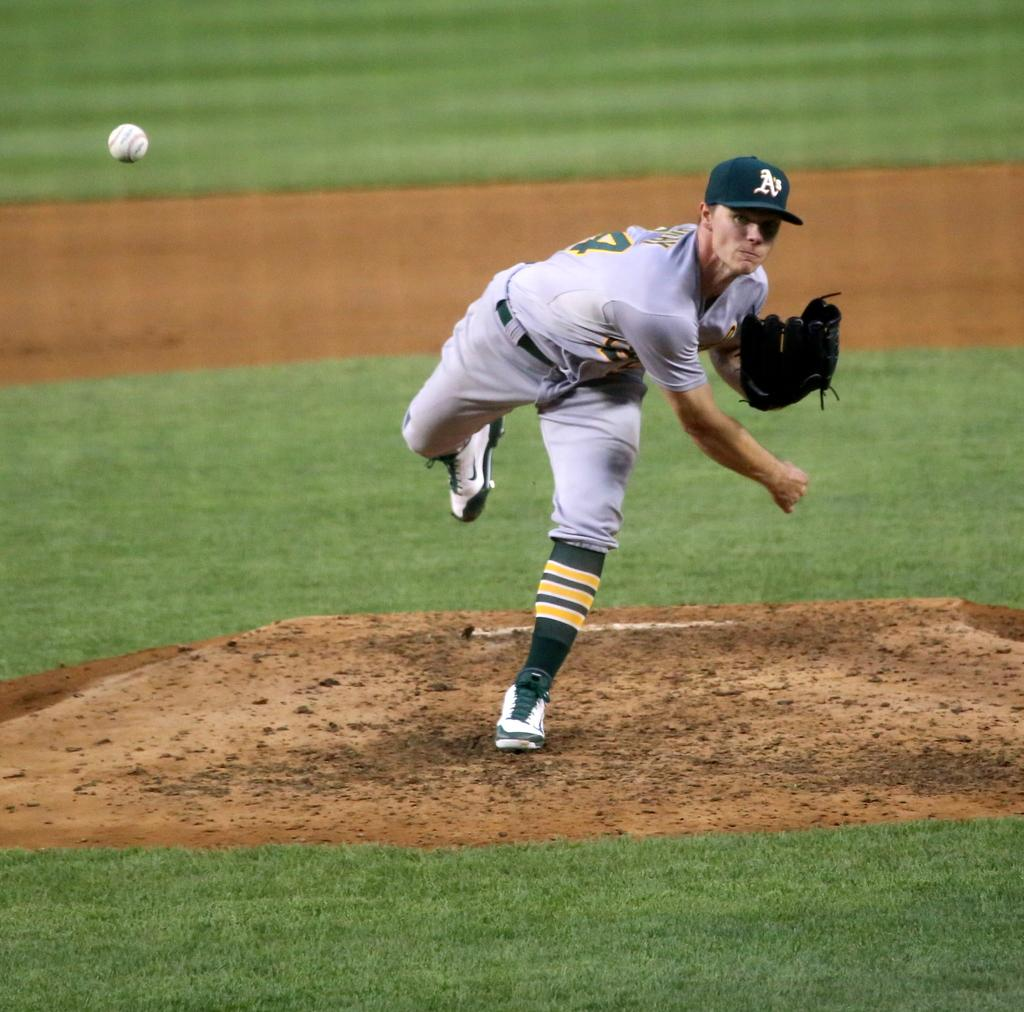<image>
Share a concise interpretation of the image provided. A pitcher for the A's has just thrown the ball. 